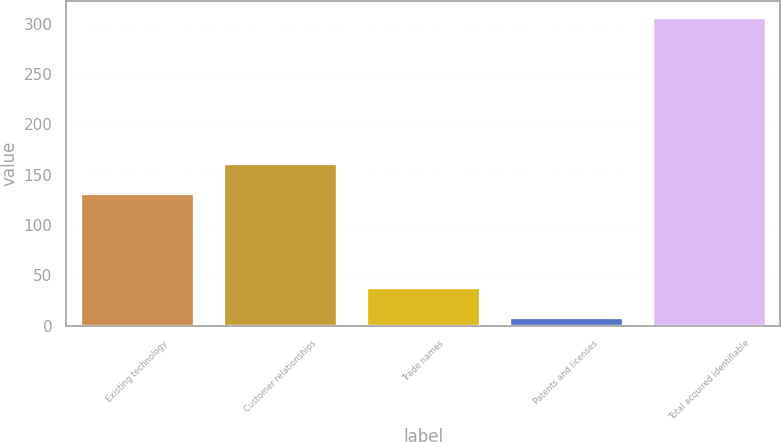Convert chart. <chart><loc_0><loc_0><loc_500><loc_500><bar_chart><fcel>Existing technology<fcel>Customer relationships<fcel>Trade names<fcel>Patents and licenses<fcel>Total acquired identifiable<nl><fcel>132<fcel>161.8<fcel>38.8<fcel>9<fcel>307<nl></chart> 